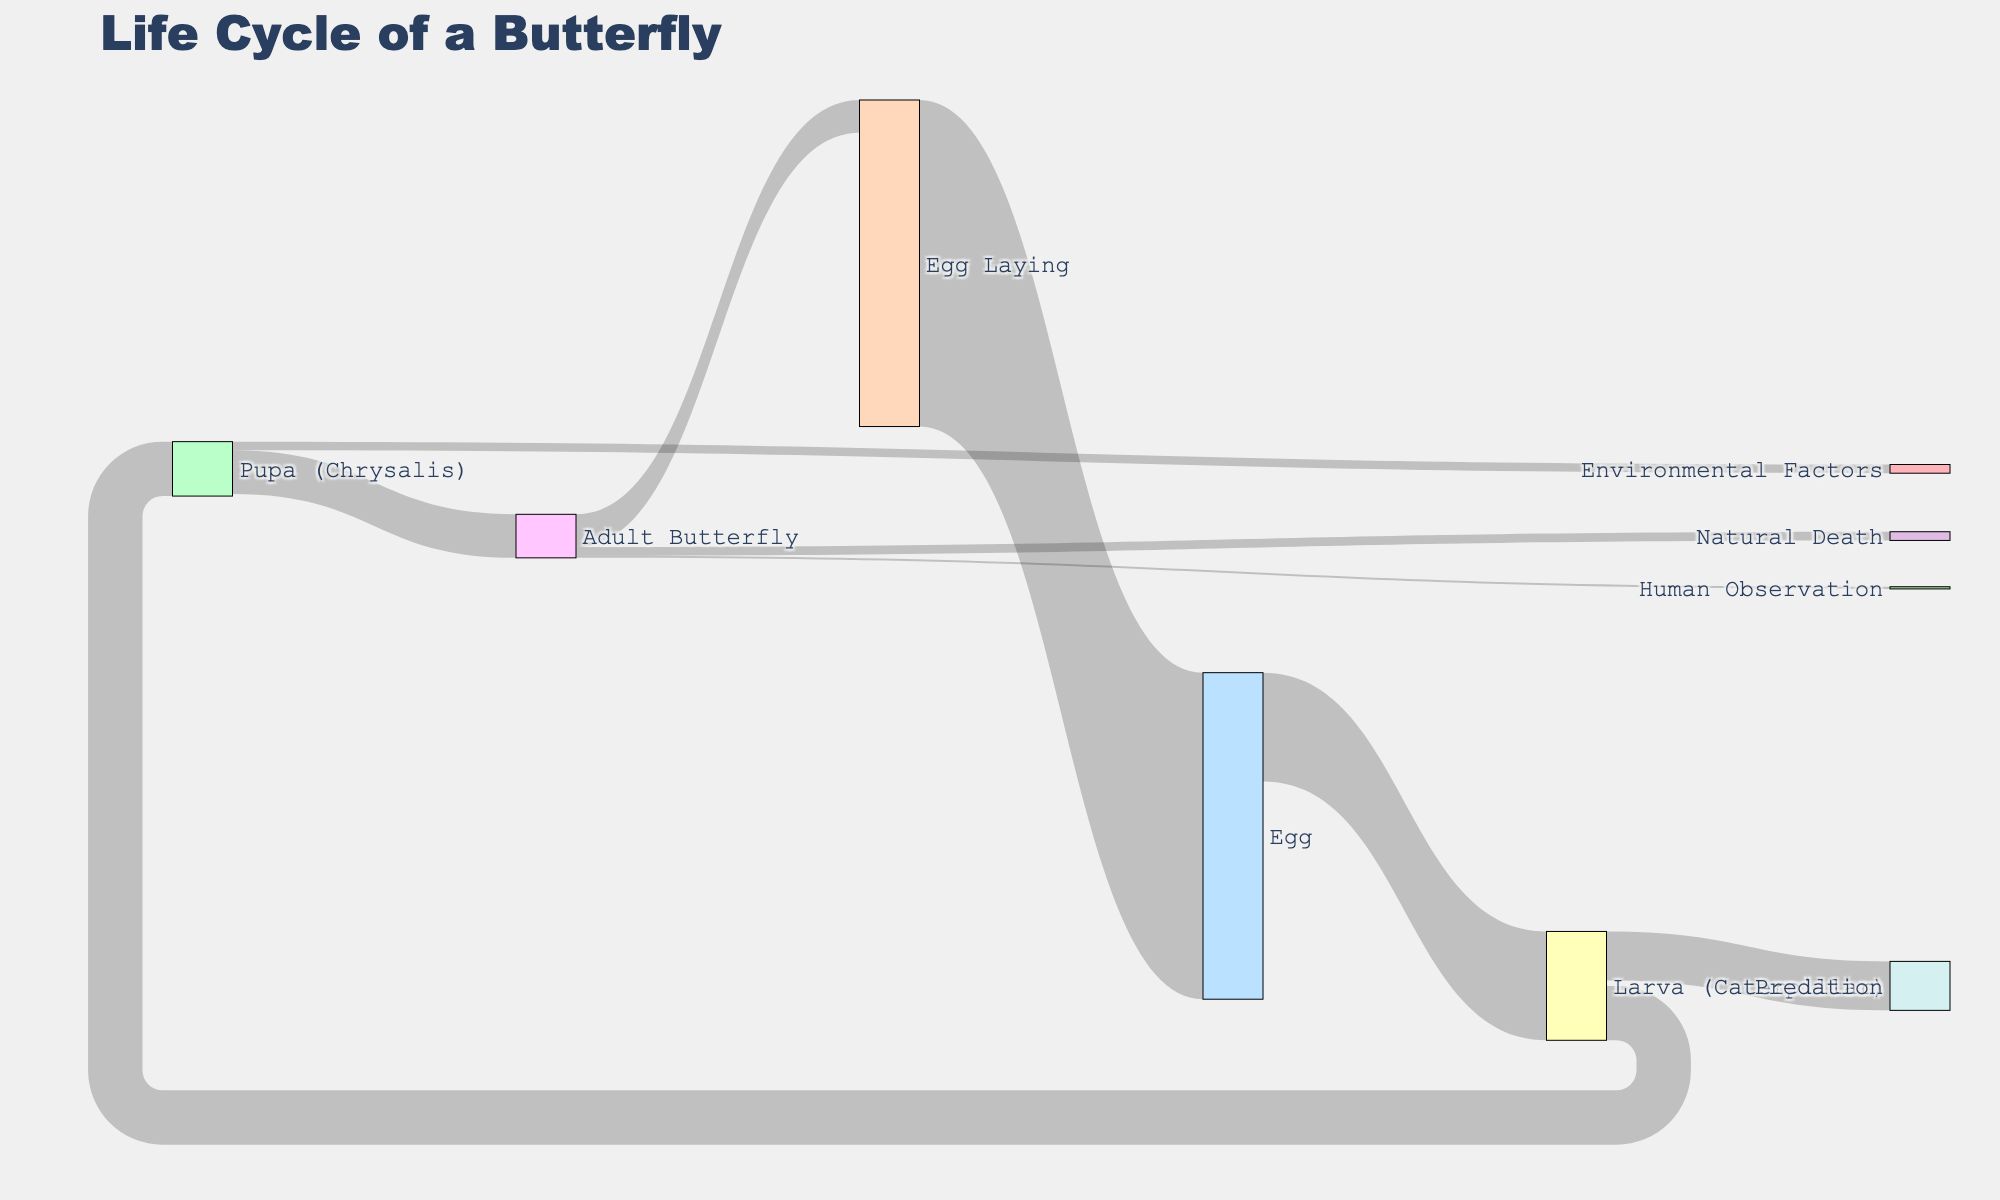Which stage has the highest initial number of individuals? The 'Egg' stage starts with the largest number of individuals. This can be observed from the initial sources identifying 'Egg' feeding into 'Larva (Caterpillar)' with the highest value of 1000.
Answer: Egg What is the total number of caterpillars that do not reach the chrysalis stage? To find this, sum up the number of caterpillars that are predated (450) and those that turn into pupae (500): 1000 - 500 + 450 = 450.
Answer: 450 How many butterflies are observed by humans? Observing the figure, the 'Adult Butterfly' flows to 'Human Observation' with a value of 20.
Answer: 20 Which target receives the smallest number of individuals from the 'Adult Butterfly' stage? Examining the targets linked to 'Adult Butterfly,' 'Natural Death' (80), 'Egg Laying' (300), and 'Human Observation' (20), 'Human Observation' has the smallest value.
Answer: Human Observation What is the net change in population from 'Pupa (Chrysalis)' to 'Adult Butterfly'? The population transitioning from 'Pupa (Chrysalis)' to 'Adult Butterfly' is 400, while another 80 die due to environmental factors, resulting in 400 - 80 = 320 reaching adulthood.
Answer: 320 